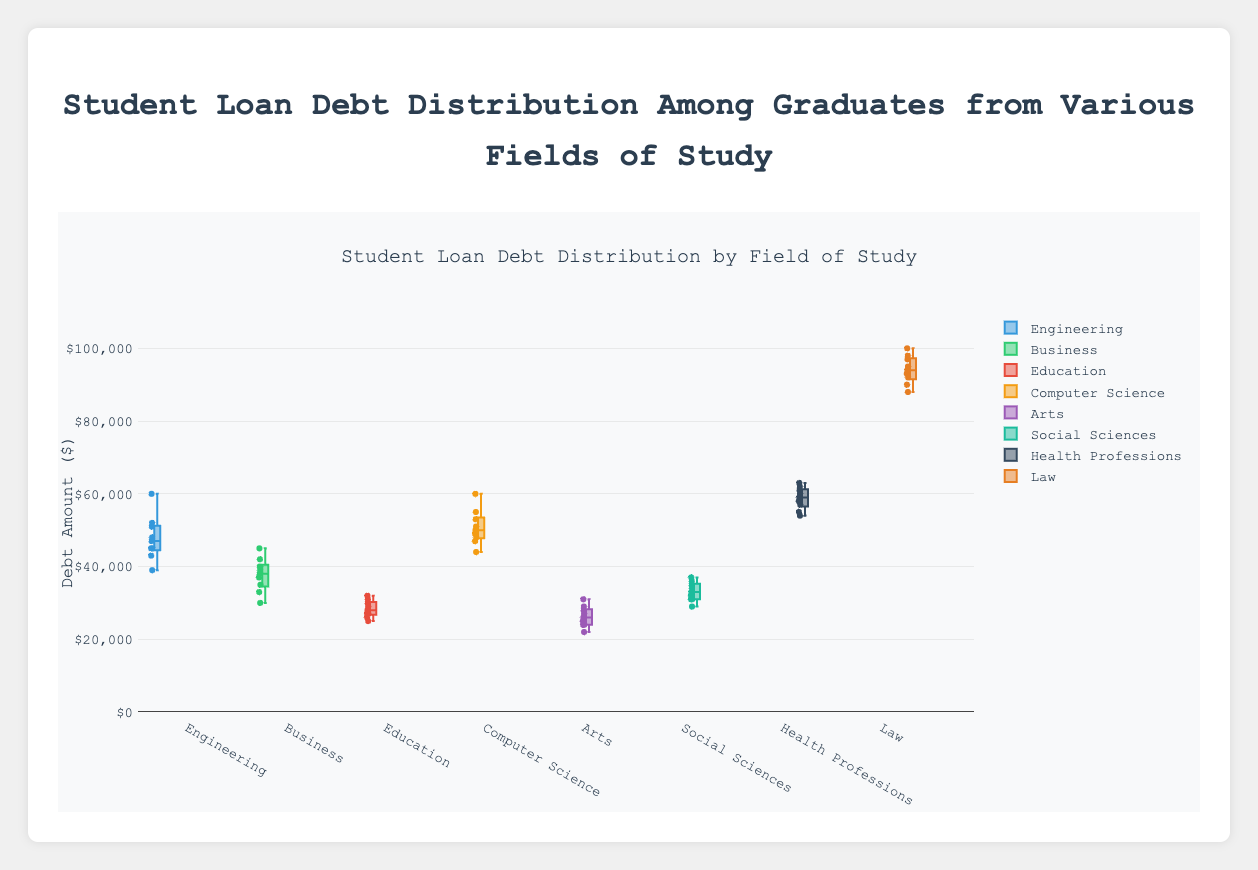What's the median student loan debt for Engineering graduates? The median value can be found by arranging the data in ascending order and finding the middle number. The sorted values are 39000, 43000, 45000, 45000, 47000, 48000, 51000, 52000, 60000, and the middle number is the 5th value, 47000.
Answer: 47000 Which field has the highest upper quartile (75th percentile) of student loan debt? The upper quartile can be estimated by looking at the upper edge of each box in the plot. Law’s box has the highest upper quartile, as it extends the furthest up the y-axis.
Answer: Law What's the range of student loan debt for graduates in Arts? The range is found by subtracting the minimum value from the maximum value. In the Arts, the maximum value is around 31000 and the minimum value is around 22000. So, the range is 31000 - 22000.
Answer: 9000 Which field has the least variance in student loan debt? Variance can be visually estimated by looking at the spread of the data points and the interquartile range (the length of the box). Education fields show a relatively smaller box and less spread in data points compared to others.
Answer: Education What is the interquartile range (IQR) for Health Professions graduates? The IQR is found by subtracting the lower quartile (25th percentile) from the upper quartile (75th percentile). In Health Professions, the lower quartile is around 55000 and the upper quartile is around 61000. So, IQR = 61000 - 55000.
Answer: 6000 Which two fields have overlapping ranges of student loan debt? Fields have overlapping ranges of student loan debt if their boxes or whiskers touch or overlap. Business and Social Sciences have overlapping ranges as their boxes and data points intermix.
Answer: Business and Social Sciences How does the student loan debt distribution for Law graduates differ from that of Education graduates? Law graduates have a significantly higher median, upper and lower quartiles, and a wider range compared to Education graduates, indicating they typically have higher loan debts.
Answer: Higher for Law Which field has the widest spread of values (maximum range) in student loan debt? The widest spread is indicated by the largest gap between the whiskers. Law has the widest spread, stretching from around 88000 to near 100000.
Answer: Law What is the approximate median student loan debt for Computer Science graduates? The median is the middle value of the dataset. For Computer Science, the value at the center of the box is around 50000.
Answer: 50000 